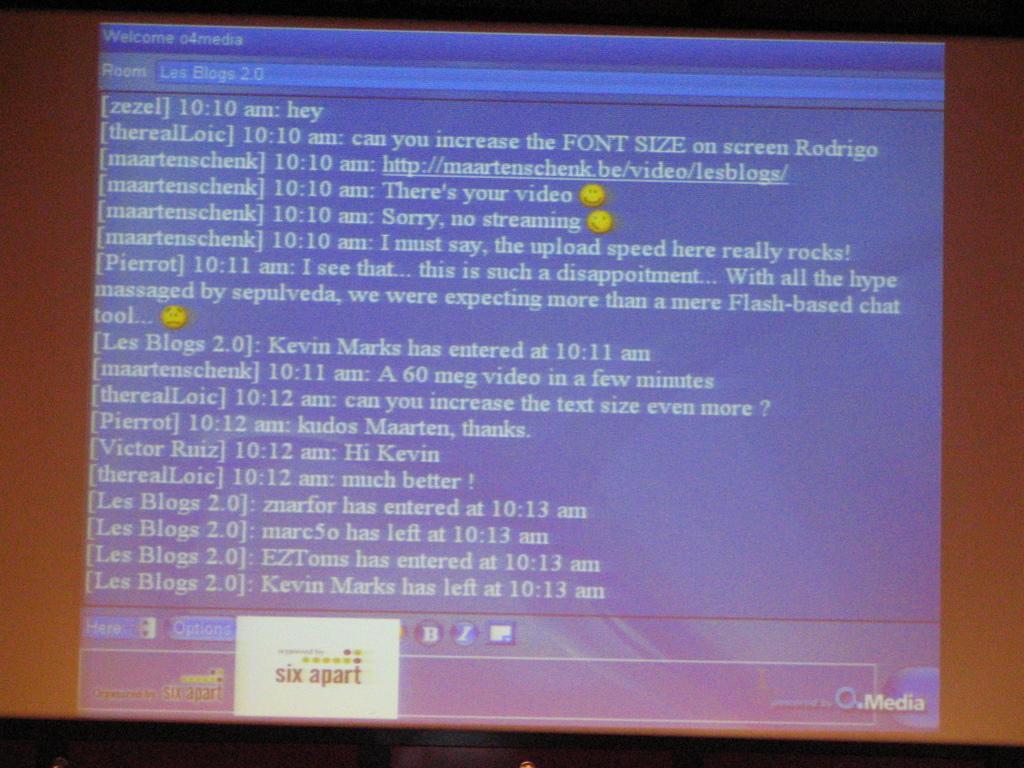Provide a one-sentence caption for the provided image. A chat is seen on a screen, and user maartenschenk sent two emojis. 